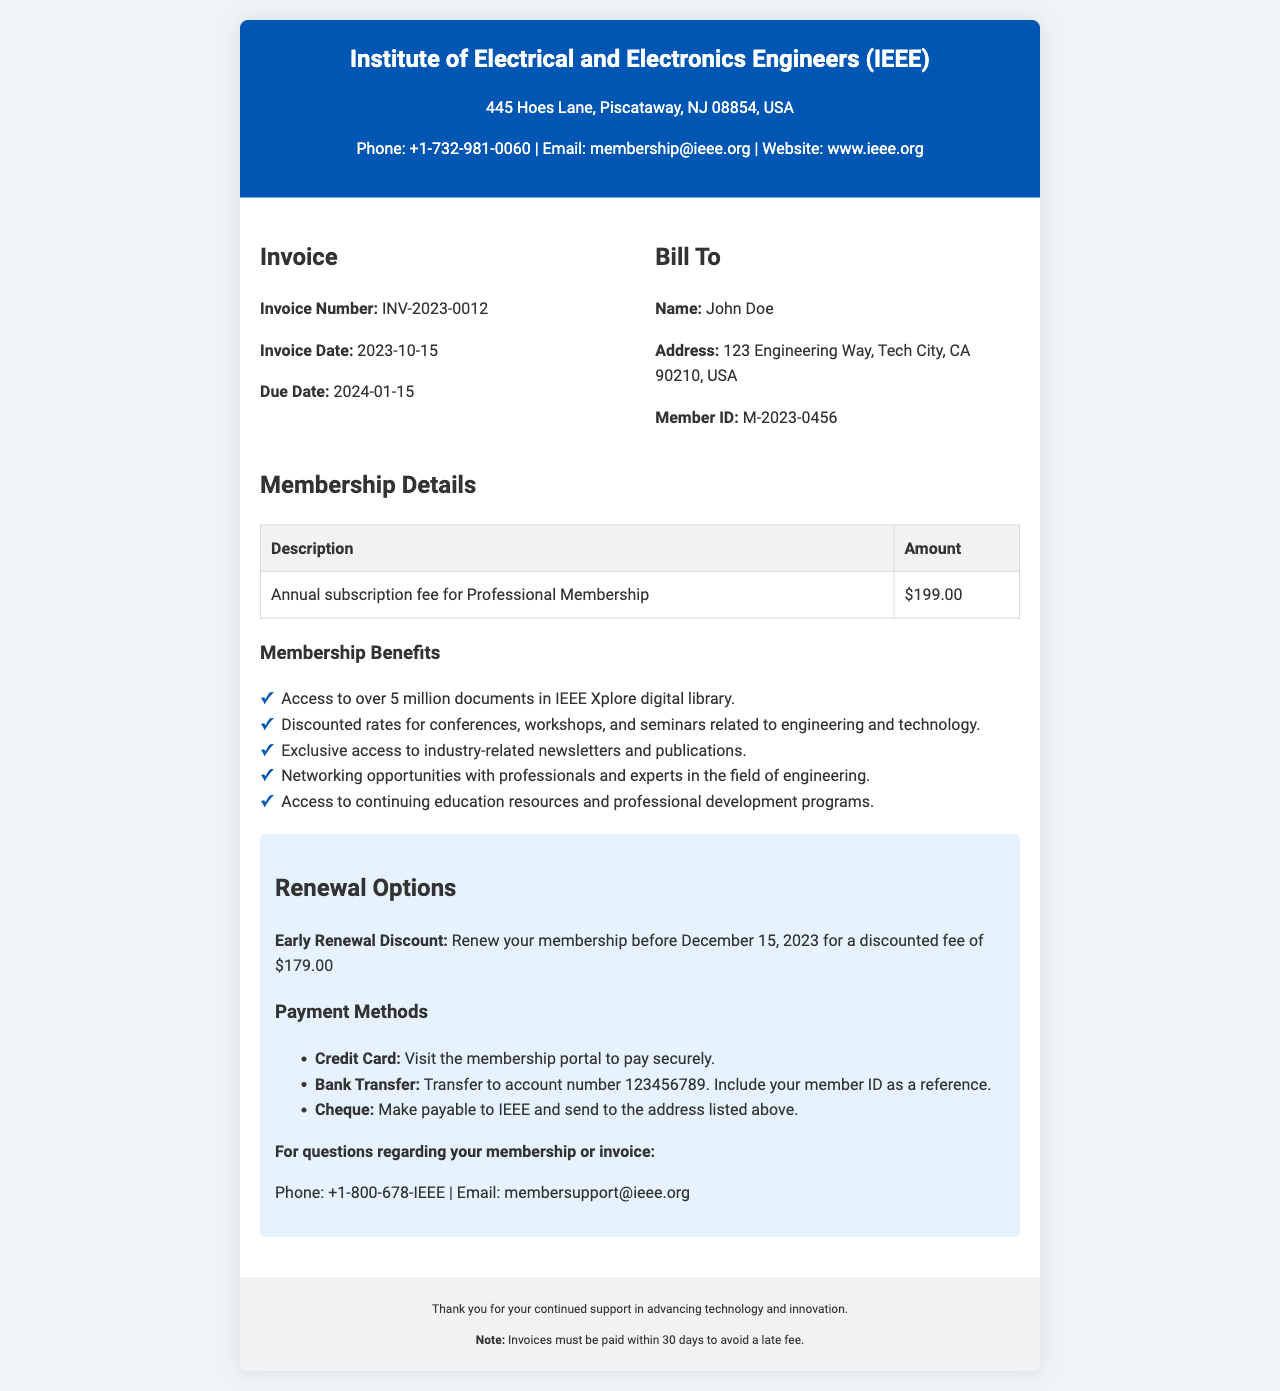What is the invoice number? The invoice number is listed under the invoice details section, providing a unique identifier for the invoice.
Answer: INV-2023-0012 What is the due date for payment? The due date is specified in the invoice details, indicating when payment should be made.
Answer: 2024-01-15 What is the amount for the annual subscription fee? The amount for the subscription fee is detailed in the membership details section.
Answer: $199.00 What is the early renewal discount fee? The early renewal discount fee is mentioned in the renewal options section, providing an incentive for prompt renewal.
Answer: $179.00 What benefits are provided with membership? The membership benefits are listed comprehensively in the membership details section, indicating what members gain from their subscription.
Answer: Access to over 5 million documents in IEEE Xplore digital library, discounted rates for conferences, exclusive access to newsletters, networking opportunities, continuing education resources How can payment be made? The payment methods are outlined in the renewal options section, listing the ways members can fulfill their payment obligations.
Answer: Credit Card, Bank Transfer, Cheque What is the address of the organization? The organization's address is listed at the top of the invoice, indicating where it is located.
Answer: 445 Hoes Lane, Piscataway, NJ 08854, USA What is the membership ID for the bill recipient? The membership ID is provided in the bill to section, identifying the member uniquely.
Answer: M-2023-0456 